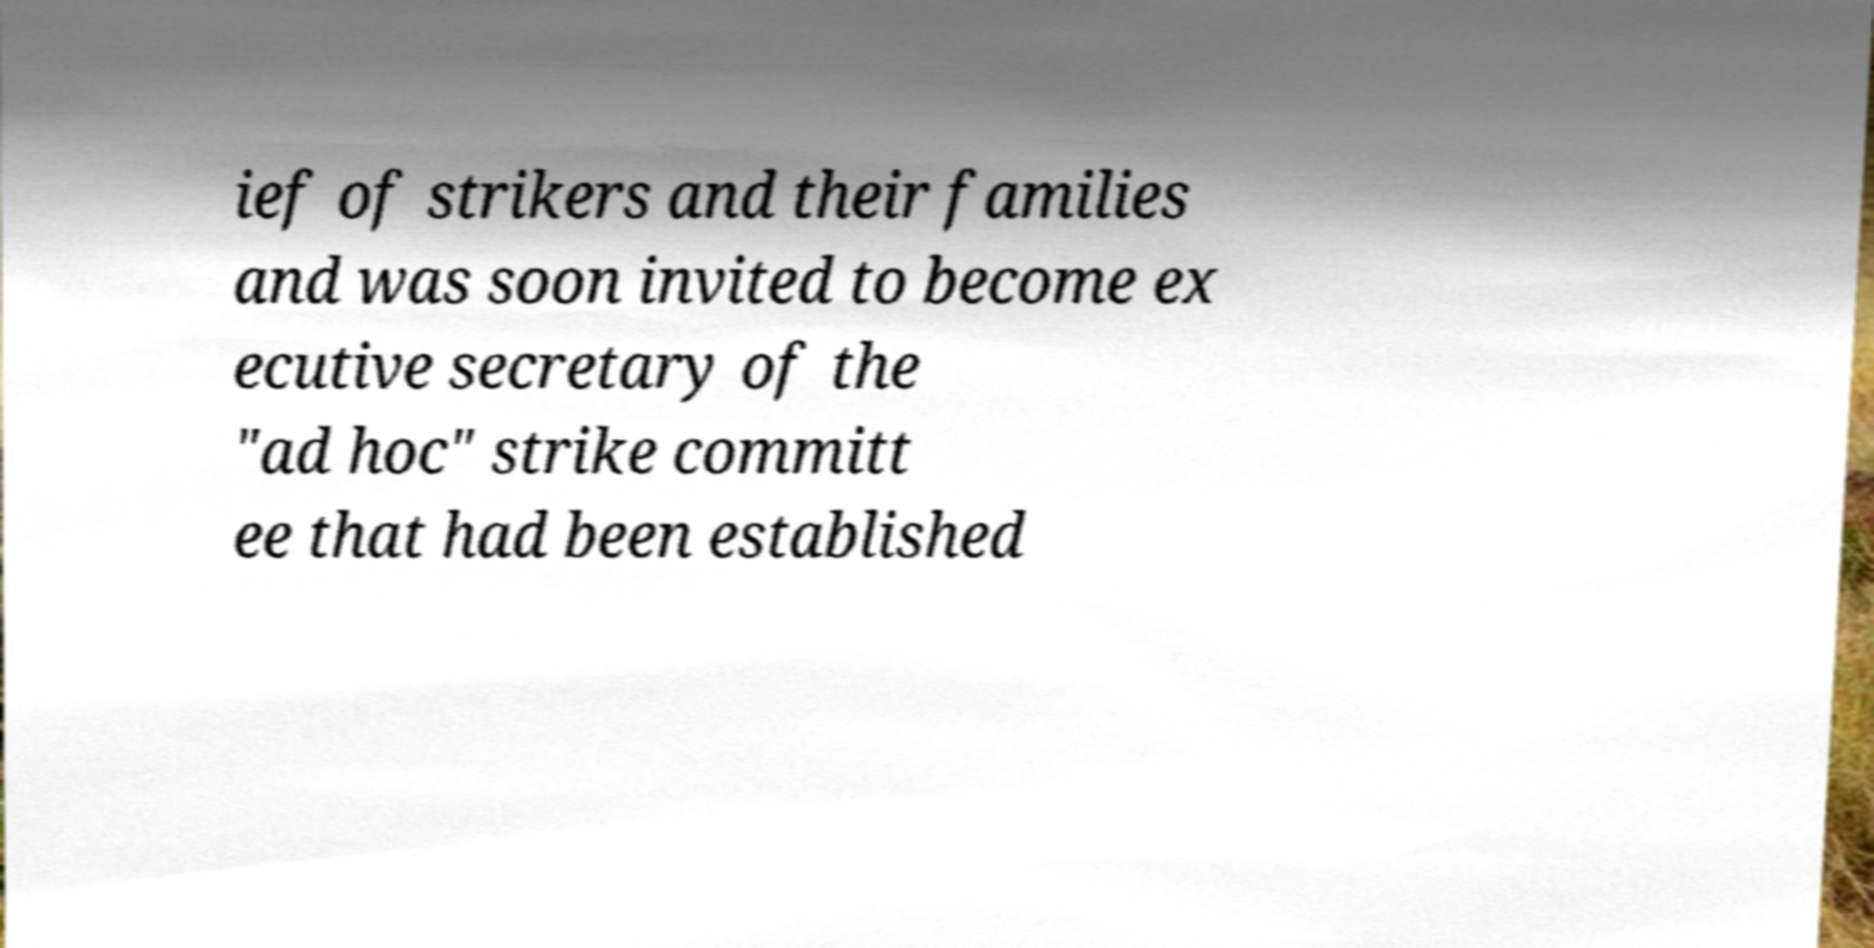Could you extract and type out the text from this image? ief of strikers and their families and was soon invited to become ex ecutive secretary of the "ad hoc" strike committ ee that had been established 